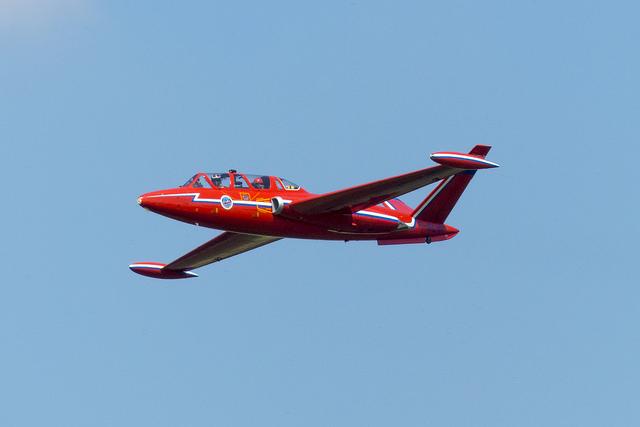What color is this plane?
Keep it brief. Red. Is a a clear sunny day?
Answer briefly. Yes. Are the wheels up?
Keep it brief. Yes. 